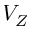Convert formula to latex. <formula><loc_0><loc_0><loc_500><loc_500>V _ { Z }</formula> 